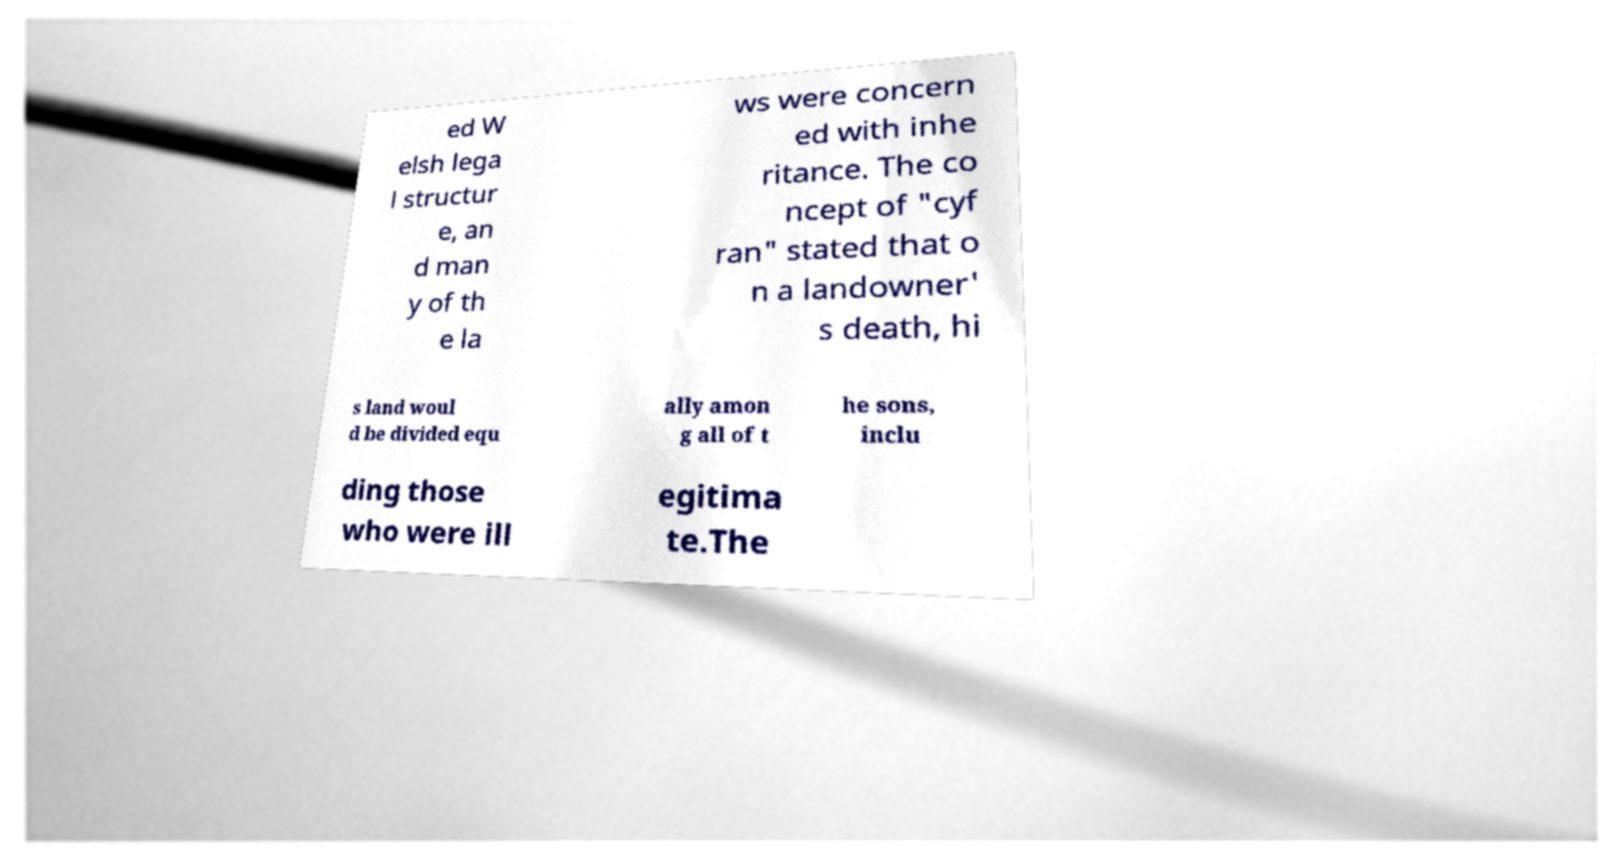Please read and relay the text visible in this image. What does it say? ed W elsh lega l structur e, an d man y of th e la ws were concern ed with inhe ritance. The co ncept of "cyf ran" stated that o n a landowner' s death, hi s land woul d be divided equ ally amon g all of t he sons, inclu ding those who were ill egitima te.The 